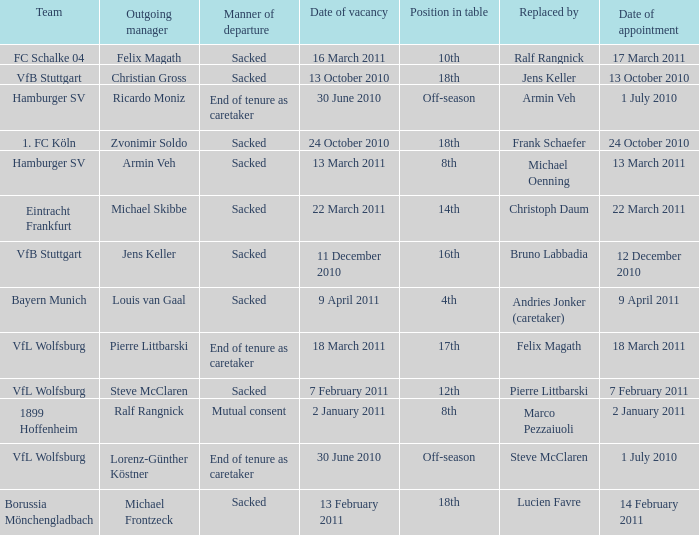When steve mcclaren is the replacer what is the manner of departure? End of tenure as caretaker. 